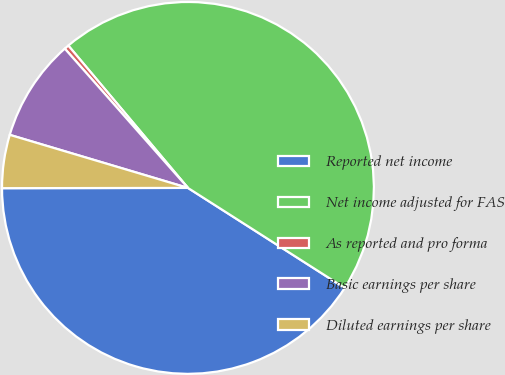Convert chart. <chart><loc_0><loc_0><loc_500><loc_500><pie_chart><fcel>Reported net income<fcel>Net income adjusted for FAS<fcel>As reported and pro forma<fcel>Basic earnings per share<fcel>Diluted earnings per share<nl><fcel>40.94%<fcel>45.17%<fcel>0.4%<fcel>8.87%<fcel>4.63%<nl></chart> 